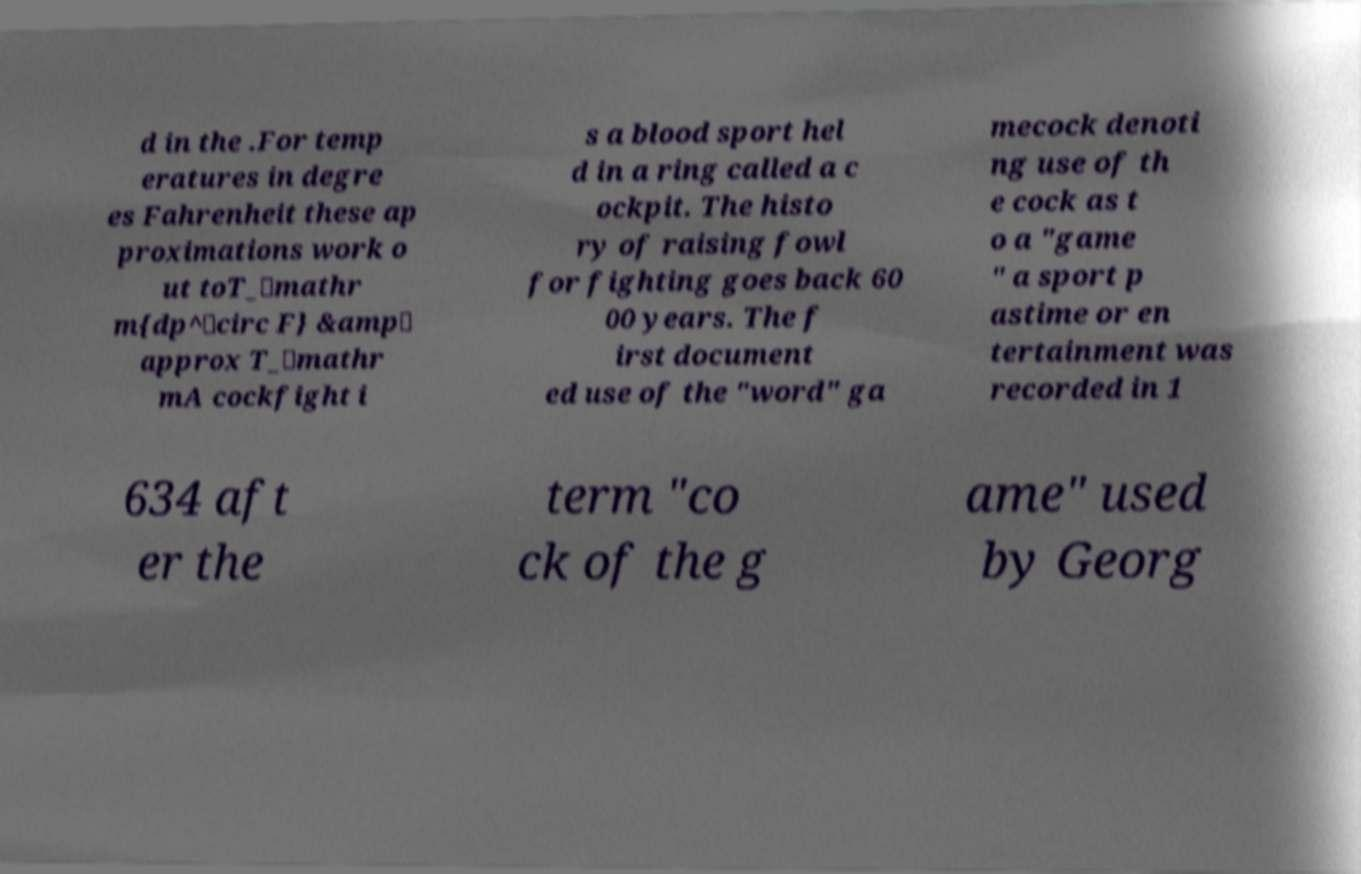For documentation purposes, I need the text within this image transcribed. Could you provide that? d in the .For temp eratures in degre es Fahrenheit these ap proximations work o ut toT_\mathr m{dp^\circ F} &amp\ approx T_\mathr mA cockfight i s a blood sport hel d in a ring called a c ockpit. The histo ry of raising fowl for fighting goes back 60 00 years. The f irst document ed use of the "word" ga mecock denoti ng use of th e cock as t o a "game " a sport p astime or en tertainment was recorded in 1 634 aft er the term "co ck of the g ame" used by Georg 